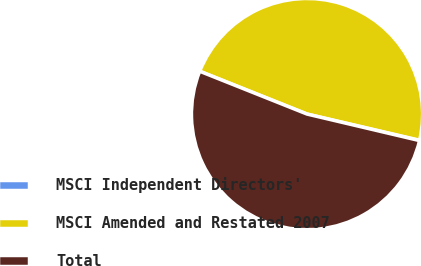Convert chart. <chart><loc_0><loc_0><loc_500><loc_500><pie_chart><fcel>MSCI Independent Directors'<fcel>MSCI Amended and Restated 2007<fcel>Total<nl><fcel>0.05%<fcel>47.59%<fcel>52.35%<nl></chart> 